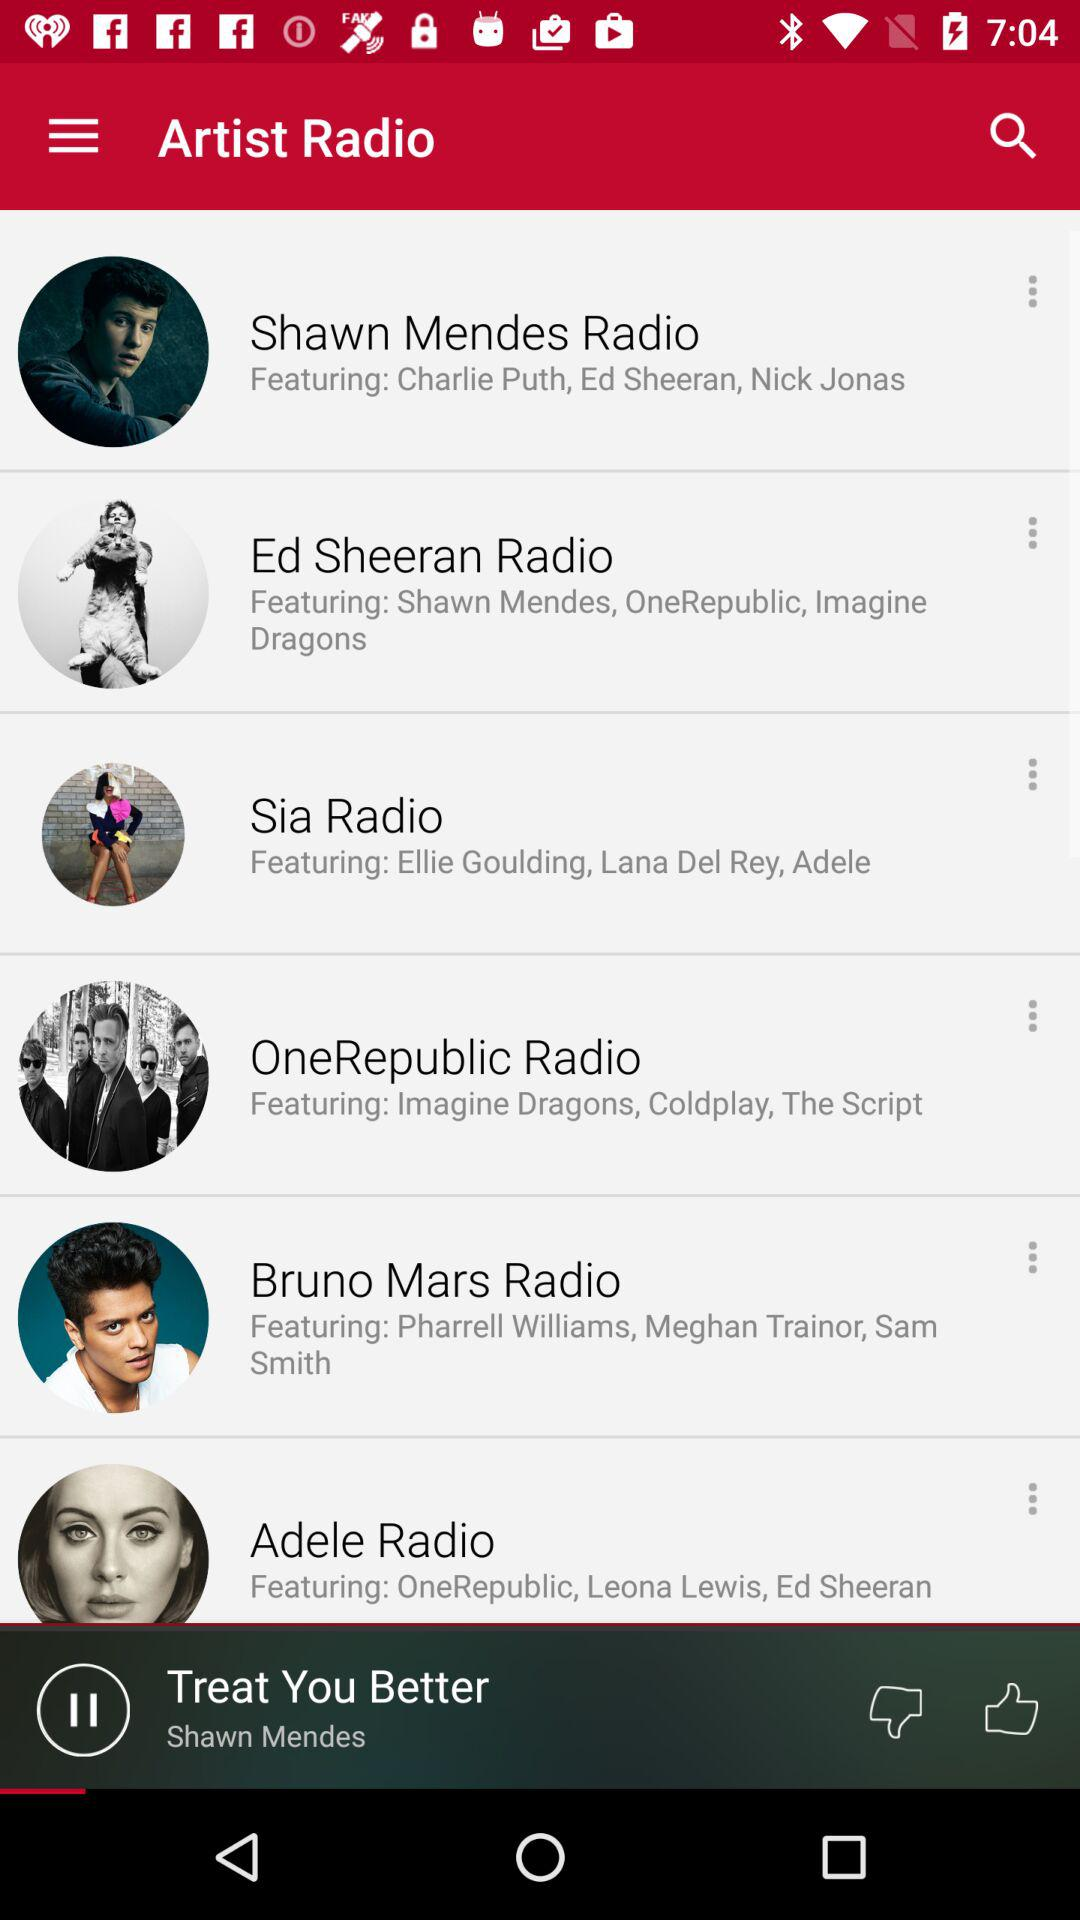How many artists are featured on the screen?
Answer the question using a single word or phrase. 6 